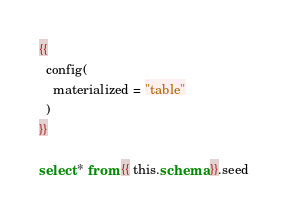Convert code to text. <code><loc_0><loc_0><loc_500><loc_500><_SQL_>{{
  config(
    materialized = "table"
  )
}}

select * from {{ this.schema }}.seed
</code> 